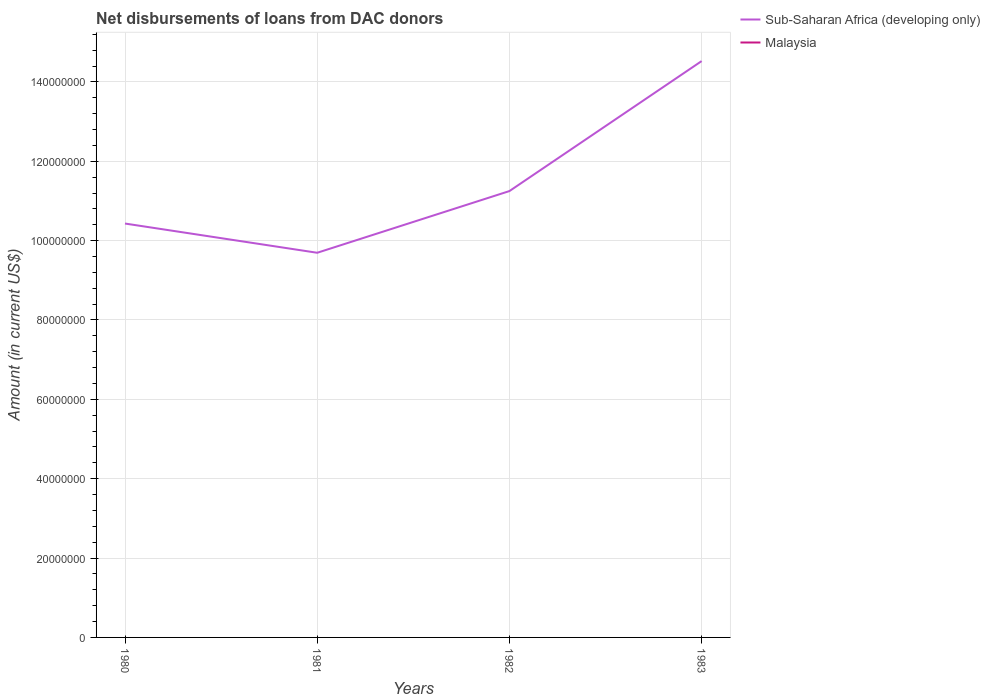How many different coloured lines are there?
Offer a very short reply. 1. Does the line corresponding to Sub-Saharan Africa (developing only) intersect with the line corresponding to Malaysia?
Make the answer very short. No. Is the number of lines equal to the number of legend labels?
Keep it short and to the point. No. Across all years, what is the maximum amount of loans disbursed in Sub-Saharan Africa (developing only)?
Make the answer very short. 9.69e+07. What is the total amount of loans disbursed in Sub-Saharan Africa (developing only) in the graph?
Keep it short and to the point. -8.18e+06. What is the difference between the highest and the second highest amount of loans disbursed in Sub-Saharan Africa (developing only)?
Keep it short and to the point. 4.83e+07. What is the difference between the highest and the lowest amount of loans disbursed in Malaysia?
Offer a terse response. 0. Is the amount of loans disbursed in Malaysia strictly greater than the amount of loans disbursed in Sub-Saharan Africa (developing only) over the years?
Your response must be concise. Yes. How many years are there in the graph?
Your response must be concise. 4. What is the difference between two consecutive major ticks on the Y-axis?
Provide a succinct answer. 2.00e+07. Are the values on the major ticks of Y-axis written in scientific E-notation?
Keep it short and to the point. No. Does the graph contain grids?
Ensure brevity in your answer.  Yes. What is the title of the graph?
Your answer should be very brief. Net disbursements of loans from DAC donors. Does "French Polynesia" appear as one of the legend labels in the graph?
Your answer should be very brief. No. What is the label or title of the X-axis?
Make the answer very short. Years. What is the label or title of the Y-axis?
Make the answer very short. Amount (in current US$). What is the Amount (in current US$) in Sub-Saharan Africa (developing only) in 1980?
Your response must be concise. 1.04e+08. What is the Amount (in current US$) in Sub-Saharan Africa (developing only) in 1981?
Provide a succinct answer. 9.69e+07. What is the Amount (in current US$) in Malaysia in 1981?
Your response must be concise. 0. What is the Amount (in current US$) of Sub-Saharan Africa (developing only) in 1982?
Offer a terse response. 1.12e+08. What is the Amount (in current US$) in Sub-Saharan Africa (developing only) in 1983?
Provide a succinct answer. 1.45e+08. What is the Amount (in current US$) of Malaysia in 1983?
Provide a succinct answer. 0. Across all years, what is the maximum Amount (in current US$) of Sub-Saharan Africa (developing only)?
Keep it short and to the point. 1.45e+08. Across all years, what is the minimum Amount (in current US$) of Sub-Saharan Africa (developing only)?
Offer a terse response. 9.69e+07. What is the total Amount (in current US$) of Sub-Saharan Africa (developing only) in the graph?
Your answer should be very brief. 4.59e+08. What is the total Amount (in current US$) in Malaysia in the graph?
Offer a very short reply. 0. What is the difference between the Amount (in current US$) of Sub-Saharan Africa (developing only) in 1980 and that in 1981?
Offer a terse response. 7.37e+06. What is the difference between the Amount (in current US$) in Sub-Saharan Africa (developing only) in 1980 and that in 1982?
Make the answer very short. -8.18e+06. What is the difference between the Amount (in current US$) of Sub-Saharan Africa (developing only) in 1980 and that in 1983?
Ensure brevity in your answer.  -4.09e+07. What is the difference between the Amount (in current US$) in Sub-Saharan Africa (developing only) in 1981 and that in 1982?
Make the answer very short. -1.55e+07. What is the difference between the Amount (in current US$) in Sub-Saharan Africa (developing only) in 1981 and that in 1983?
Ensure brevity in your answer.  -4.83e+07. What is the difference between the Amount (in current US$) of Sub-Saharan Africa (developing only) in 1982 and that in 1983?
Make the answer very short. -3.28e+07. What is the average Amount (in current US$) of Sub-Saharan Africa (developing only) per year?
Ensure brevity in your answer.  1.15e+08. What is the average Amount (in current US$) of Malaysia per year?
Provide a short and direct response. 0. What is the ratio of the Amount (in current US$) in Sub-Saharan Africa (developing only) in 1980 to that in 1981?
Keep it short and to the point. 1.08. What is the ratio of the Amount (in current US$) of Sub-Saharan Africa (developing only) in 1980 to that in 1982?
Your answer should be very brief. 0.93. What is the ratio of the Amount (in current US$) of Sub-Saharan Africa (developing only) in 1980 to that in 1983?
Offer a very short reply. 0.72. What is the ratio of the Amount (in current US$) in Sub-Saharan Africa (developing only) in 1981 to that in 1982?
Offer a very short reply. 0.86. What is the ratio of the Amount (in current US$) of Sub-Saharan Africa (developing only) in 1981 to that in 1983?
Your answer should be very brief. 0.67. What is the ratio of the Amount (in current US$) in Sub-Saharan Africa (developing only) in 1982 to that in 1983?
Ensure brevity in your answer.  0.77. What is the difference between the highest and the second highest Amount (in current US$) of Sub-Saharan Africa (developing only)?
Give a very brief answer. 3.28e+07. What is the difference between the highest and the lowest Amount (in current US$) in Sub-Saharan Africa (developing only)?
Ensure brevity in your answer.  4.83e+07. 